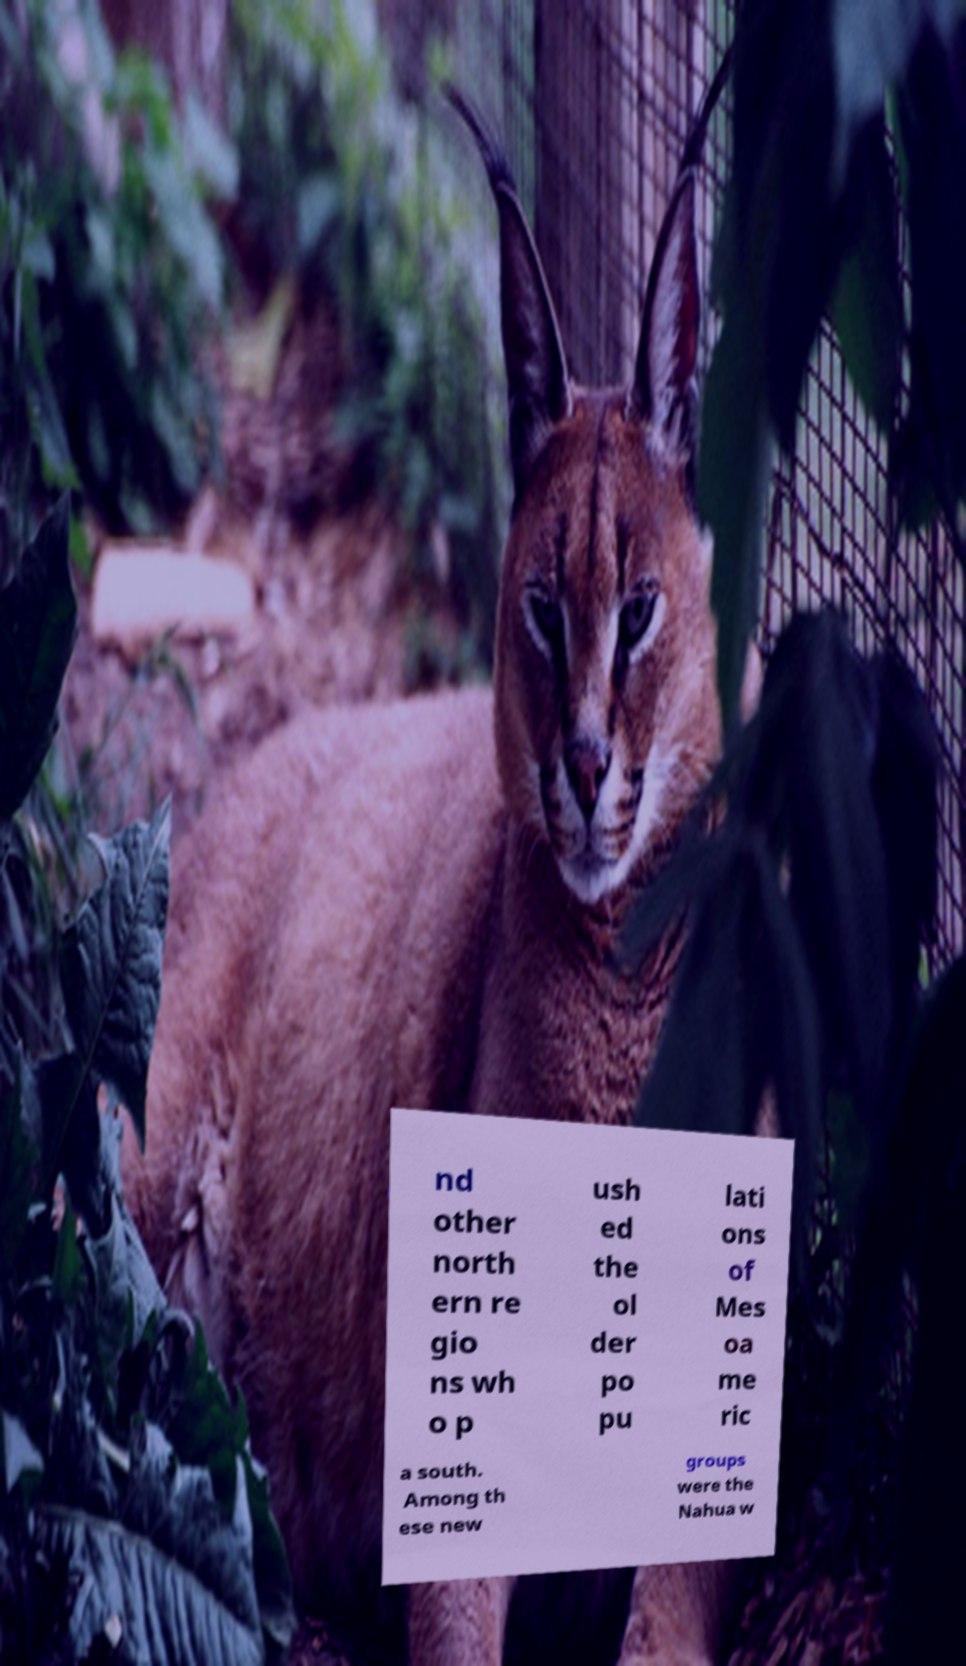Can you read and provide the text displayed in the image?This photo seems to have some interesting text. Can you extract and type it out for me? nd other north ern re gio ns wh o p ush ed the ol der po pu lati ons of Mes oa me ric a south. Among th ese new groups were the Nahua w 